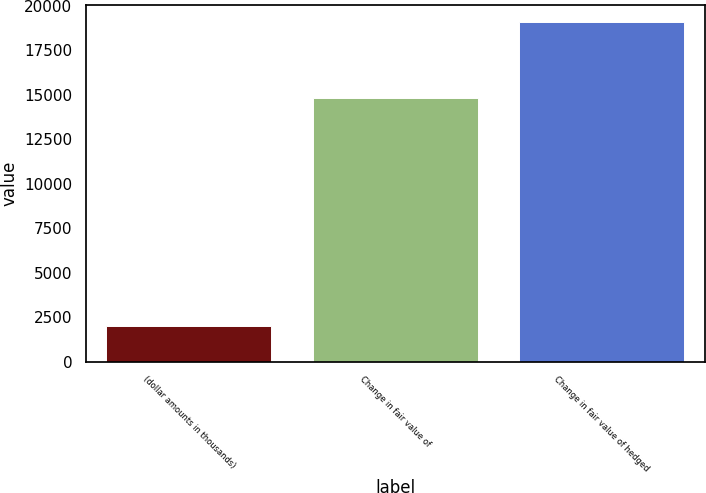Convert chart. <chart><loc_0><loc_0><loc_500><loc_500><bar_chart><fcel>(dollar amounts in thousands)<fcel>Change in fair value of<fcel>Change in fair value of hedged<nl><fcel>2013<fcel>14818.8<fcel>19087.4<nl></chart> 